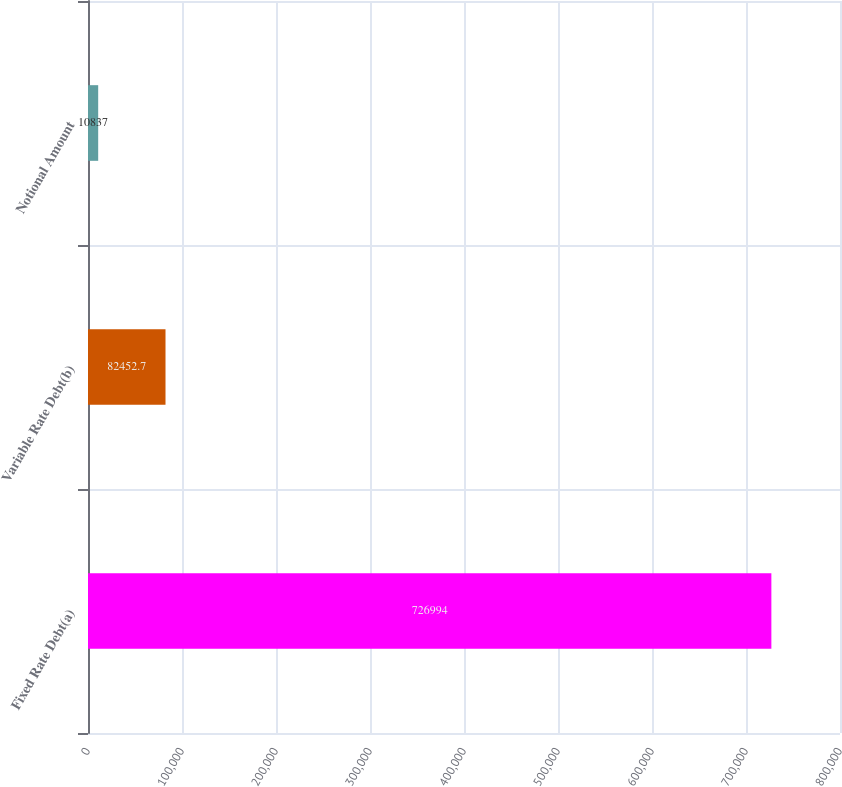<chart> <loc_0><loc_0><loc_500><loc_500><bar_chart><fcel>Fixed Rate Debt(a)<fcel>Variable Rate Debt(b)<fcel>Notional Amount<nl><fcel>726994<fcel>82452.7<fcel>10837<nl></chart> 